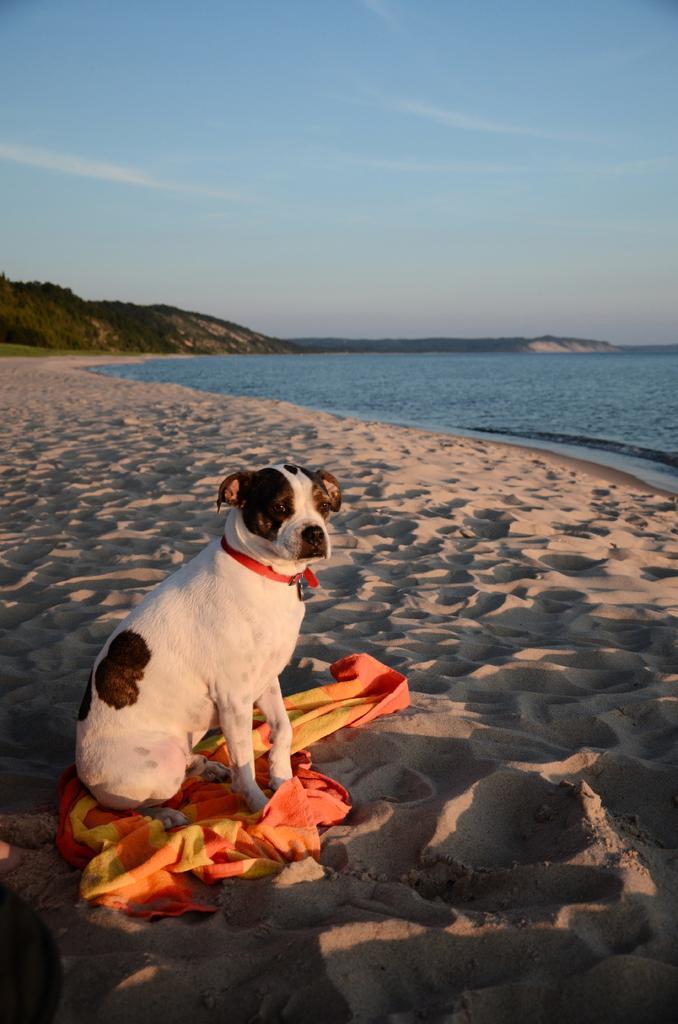Describe this image in one or two sentences. In this picture we can see a dog with a cloth sitting on the sand beside a river with blue water. In the background, we can see trees, mountains. The sky is blue. 